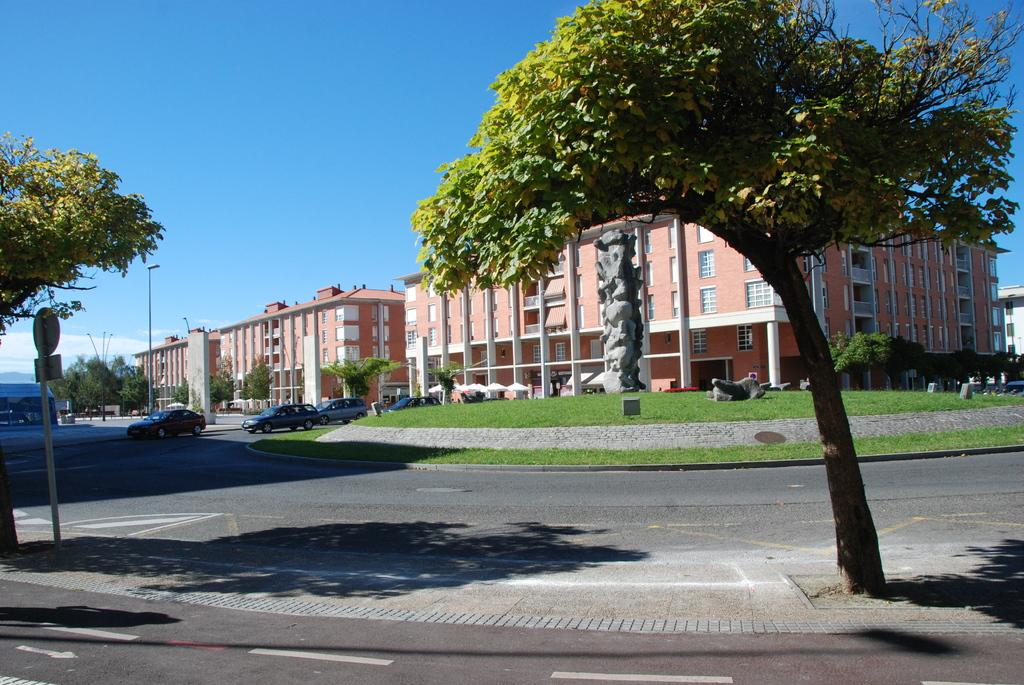What type of structures can be seen in the image? There are buildings in the image. What other natural elements are present in the image? There are trees in the image. Are there any vehicles visible in the image? Yes, there are cars visible in the image. What type of ground cover is present in the image? There is grass on the ground in the image. How would you describe the sky in the image? The sky is blue and cloudy in the image. Can you see a locket hanging from one of the trees in the image? There is no locket present in the image; it features buildings, trees, cars, grass, and a blue, cloudy sky. 